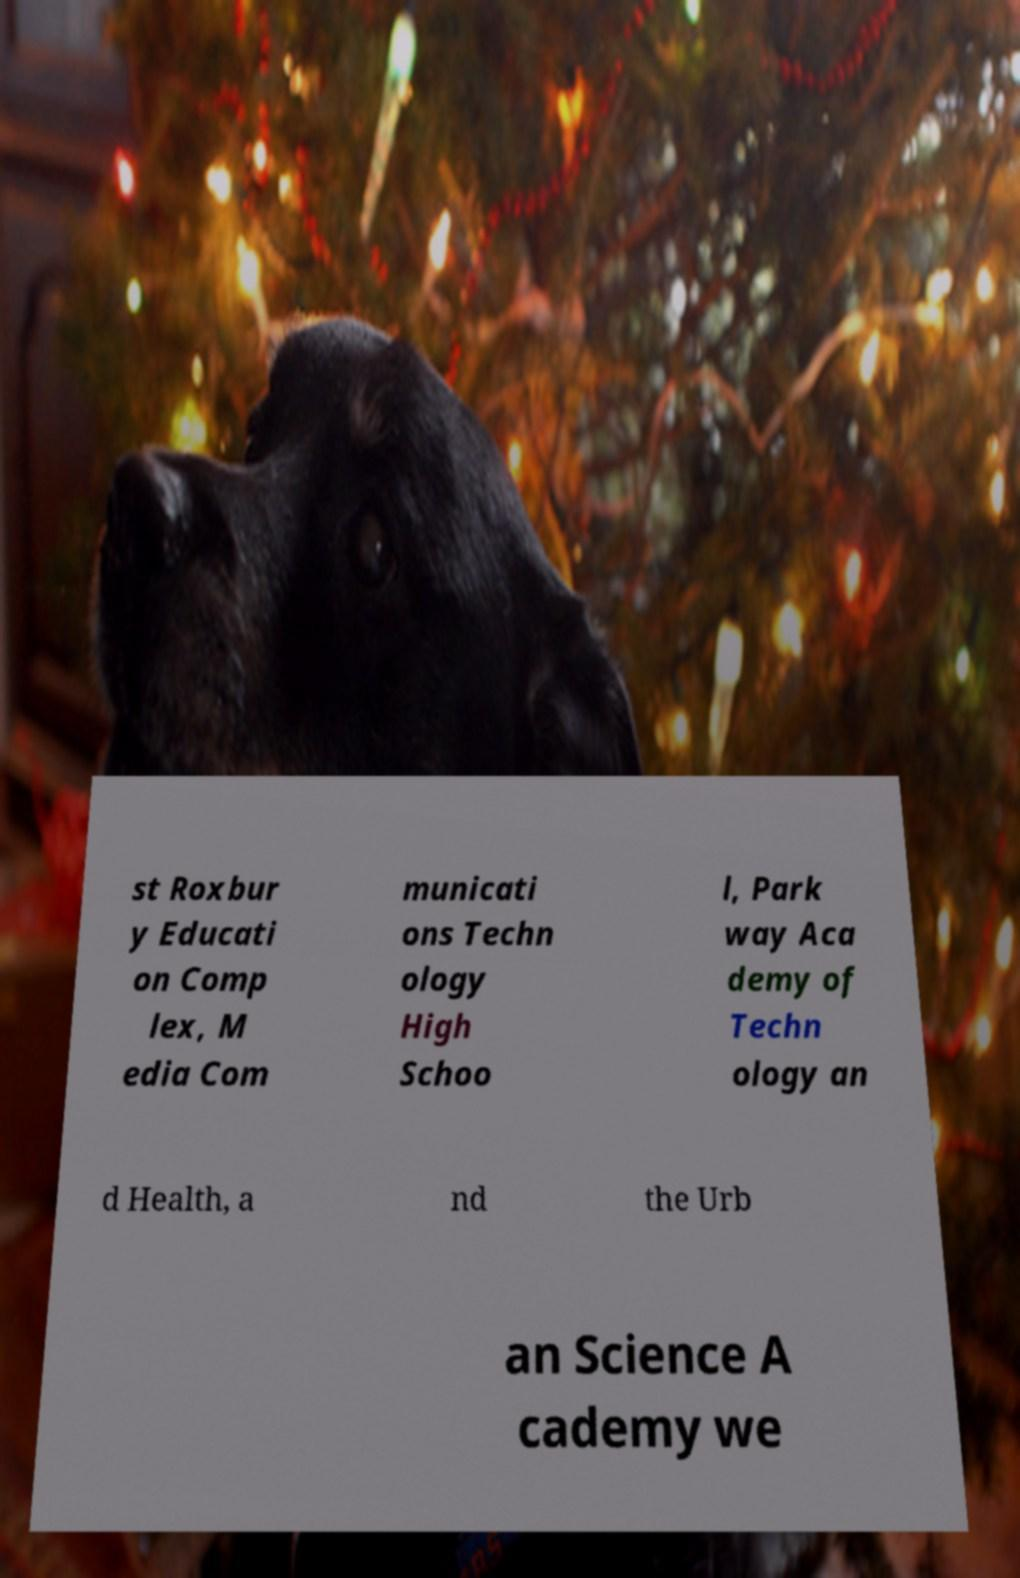Please identify and transcribe the text found in this image. st Roxbur y Educati on Comp lex, M edia Com municati ons Techn ology High Schoo l, Park way Aca demy of Techn ology an d Health, a nd the Urb an Science A cademy we 